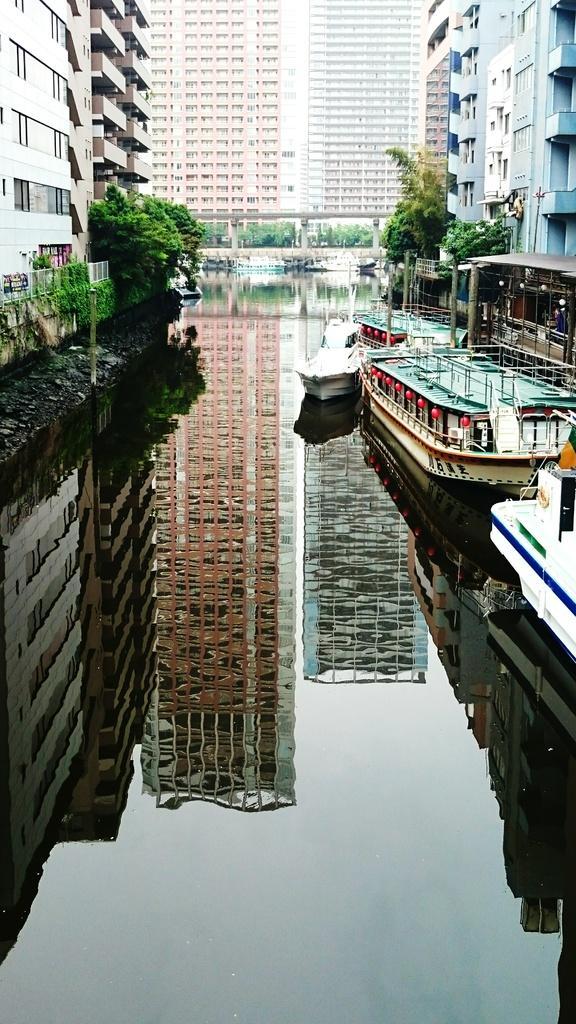Describe this image in one or two sentences. In the foreground I can see creepers and boats in the water. In the background I can see buildings, windows, bridge and trees. This image is taken during a day. 